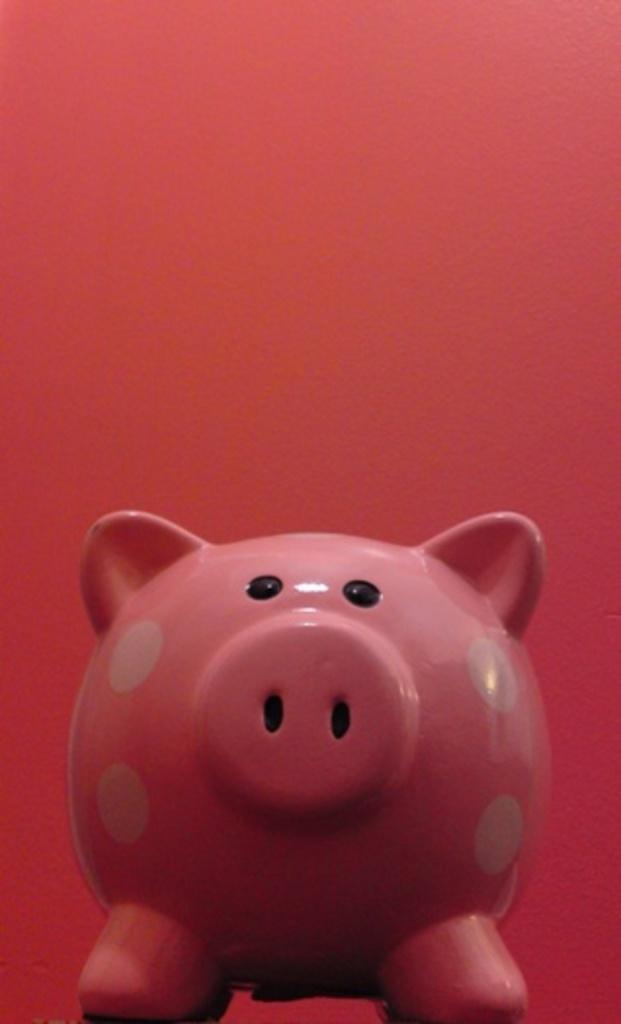Can you describe this image briefly? In the picture I can see pink color piggy and the background of the image is in red color. 